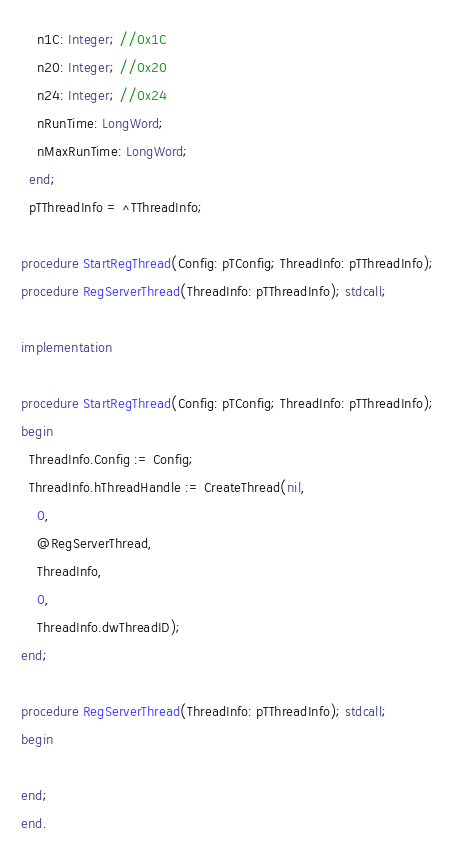<code> <loc_0><loc_0><loc_500><loc_500><_Pascal_>    n1C: Integer; //0x1C
    n20: Integer; //0x20
    n24: Integer; //0x24
    nRunTime: LongWord;
    nMaxRunTime: LongWord;
  end;
  pTThreadInfo = ^TThreadInfo;
  
procedure StartRegThread(Config: pTConfig; ThreadInfo: pTThreadInfo);
procedure RegServerThread(ThreadInfo: pTThreadInfo); stdcall;

implementation

procedure StartRegThread(Config: pTConfig; ThreadInfo: pTThreadInfo);
begin
  ThreadInfo.Config := Config;
  ThreadInfo.hThreadHandle := CreateThread(nil,
    0,
    @RegServerThread,
    ThreadInfo,
    0,
    ThreadInfo.dwThreadID);
end;

procedure RegServerThread(ThreadInfo: pTThreadInfo); stdcall;
begin

end;
end.
</code> 